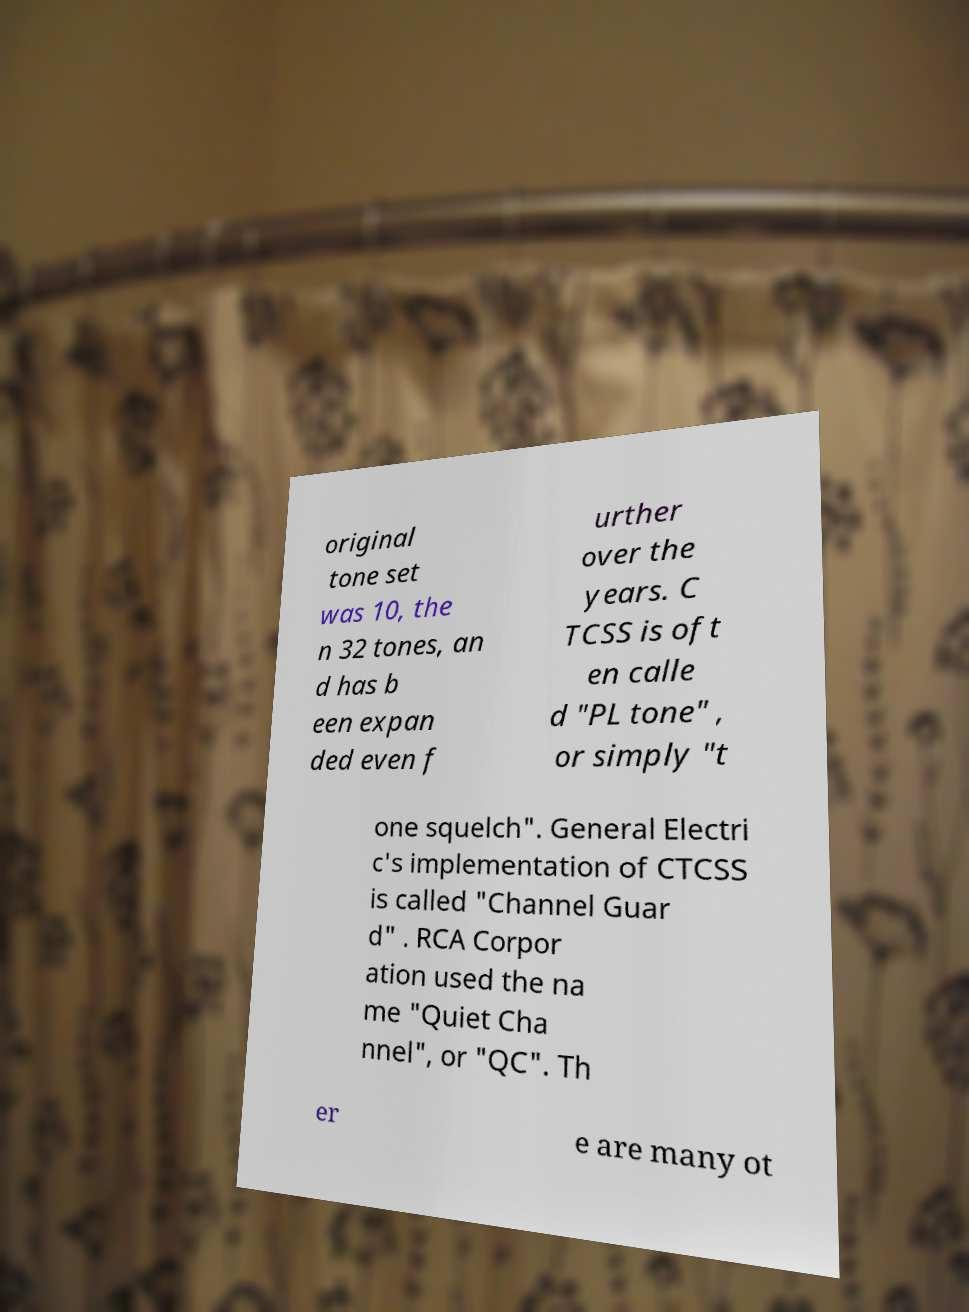Could you assist in decoding the text presented in this image and type it out clearly? original tone set was 10, the n 32 tones, an d has b een expan ded even f urther over the years. C TCSS is oft en calle d "PL tone" , or simply "t one squelch". General Electri c's implementation of CTCSS is called "Channel Guar d" . RCA Corpor ation used the na me "Quiet Cha nnel", or "QC". Th er e are many ot 